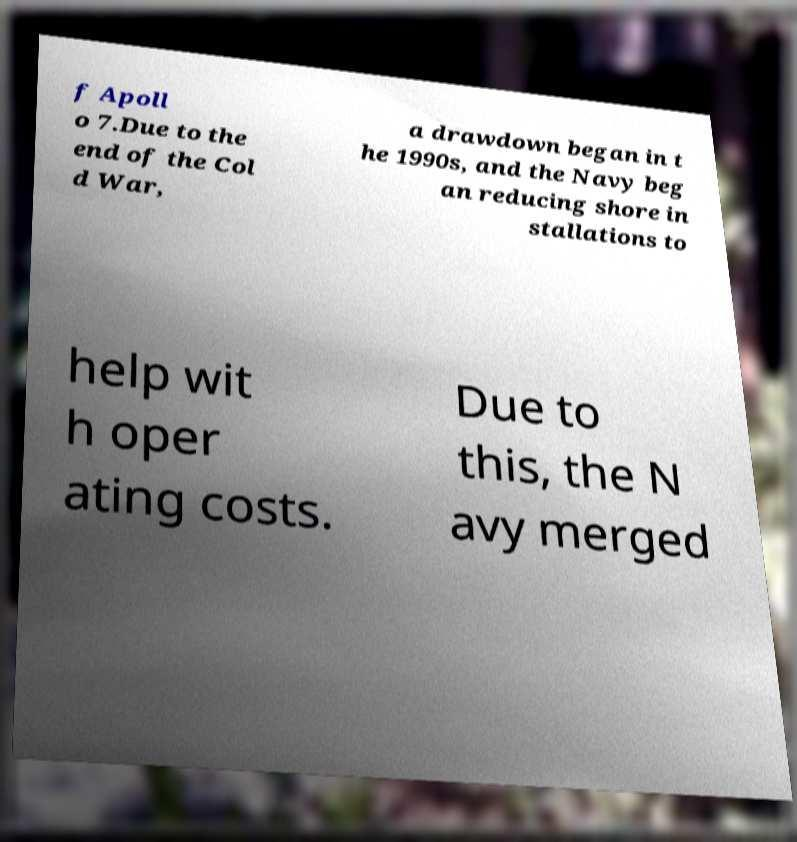Please identify and transcribe the text found in this image. f Apoll o 7.Due to the end of the Col d War, a drawdown began in t he 1990s, and the Navy beg an reducing shore in stallations to help wit h oper ating costs. Due to this, the N avy merged 